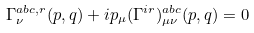Convert formula to latex. <formula><loc_0><loc_0><loc_500><loc_500>\Gamma ^ { a b c , r } _ { \nu } ( p , q ) + i p _ { \mu } ( \Gamma ^ { i r } ) ^ { a b c } _ { \mu \nu } ( p , q ) = 0</formula> 